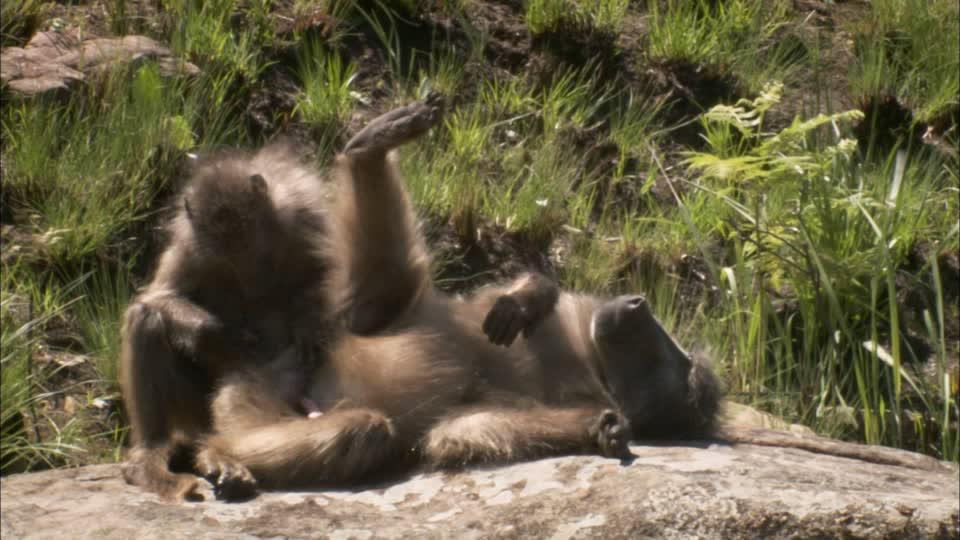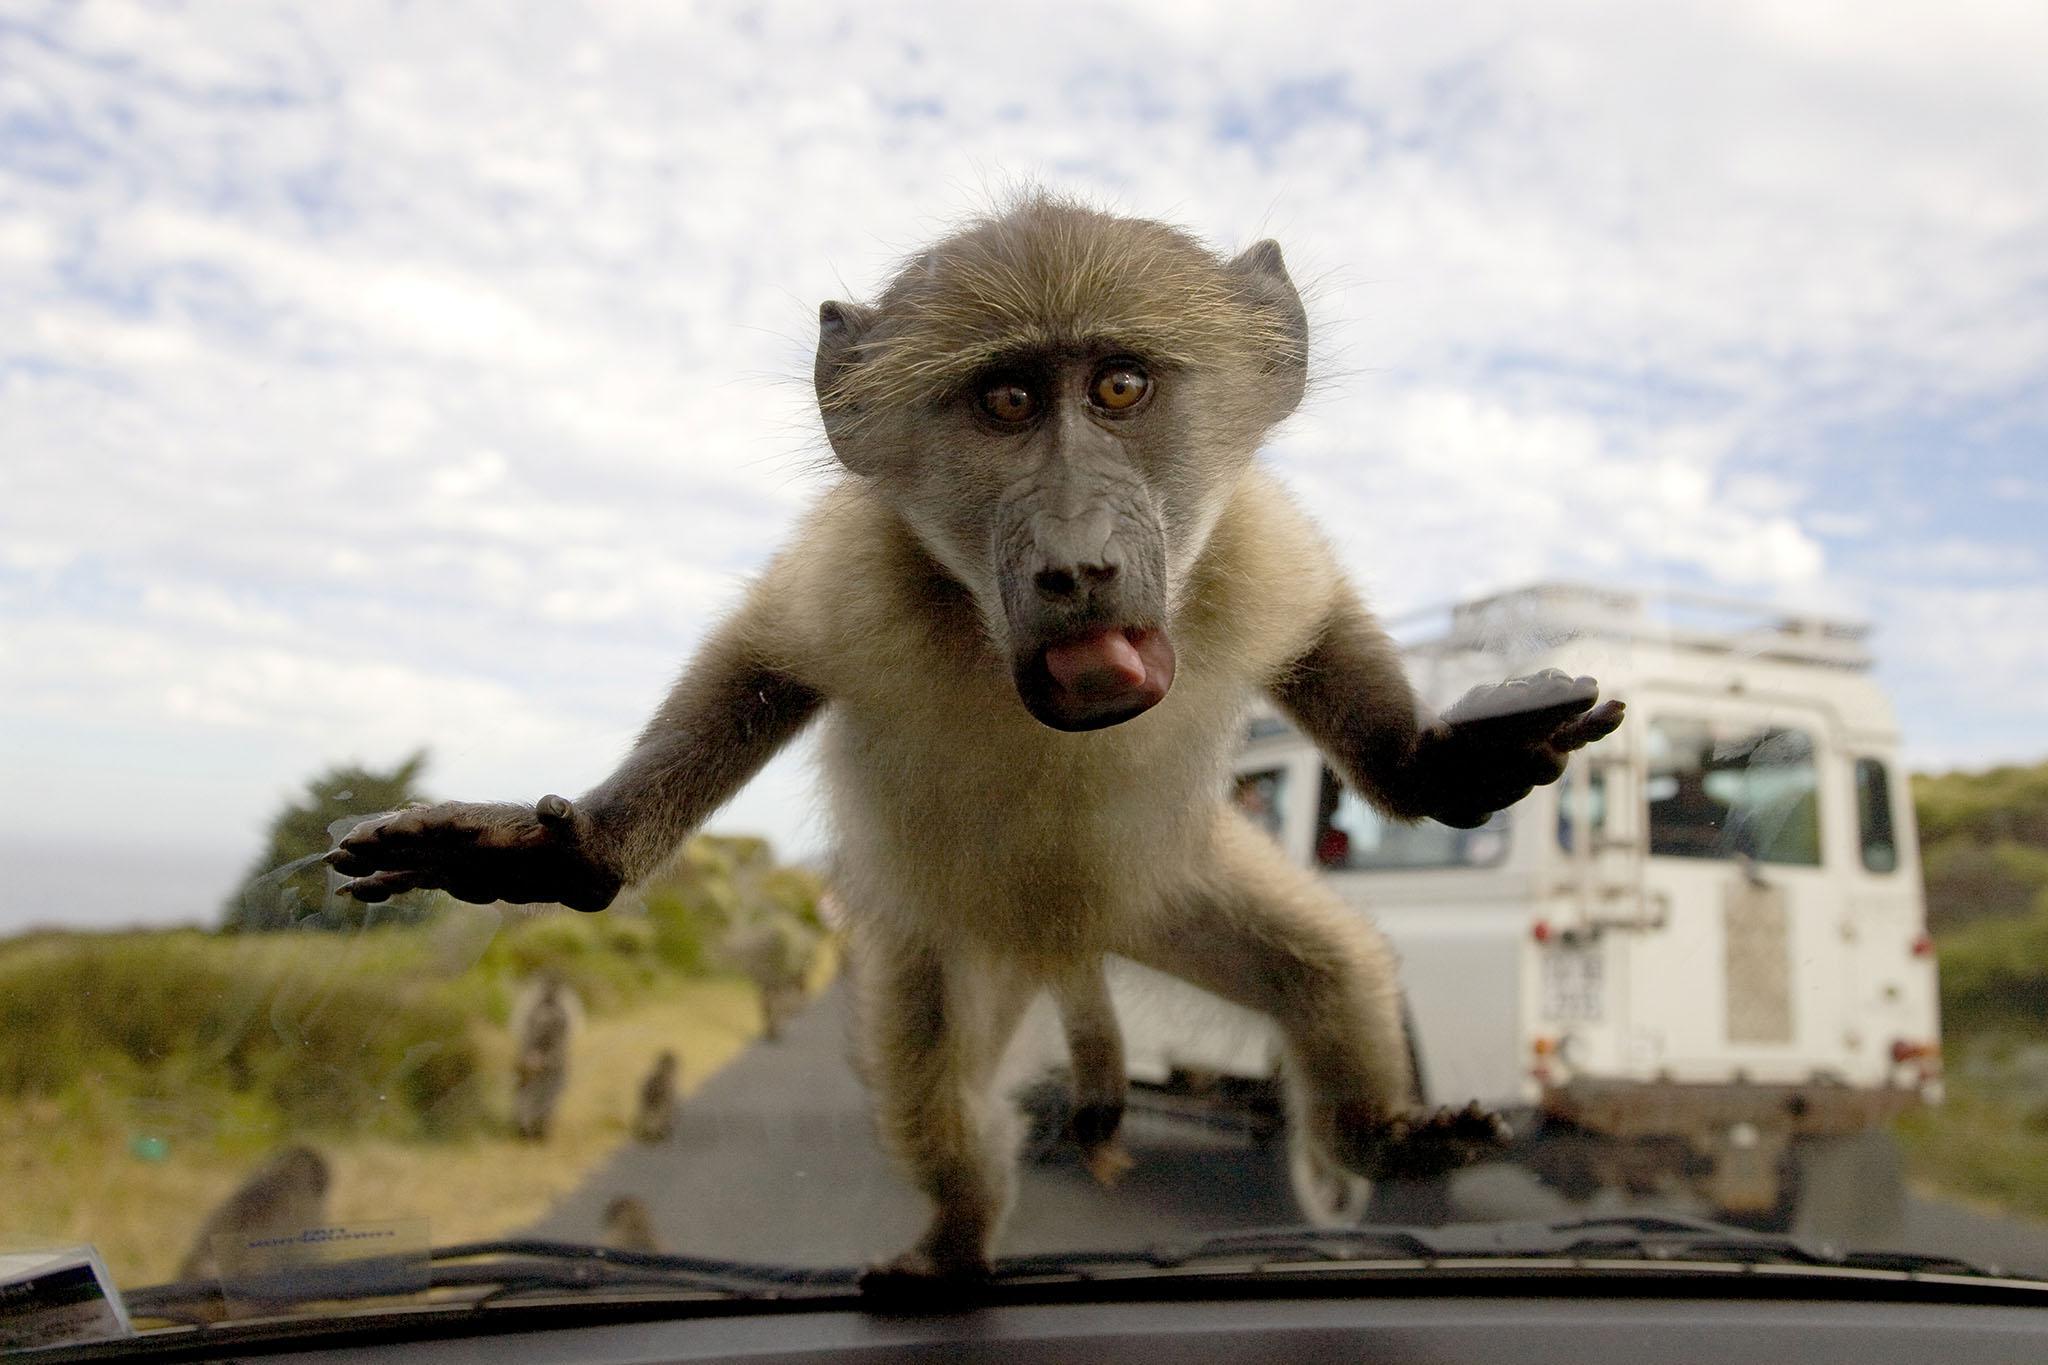The first image is the image on the left, the second image is the image on the right. For the images shown, is this caption "An older woman is showing some affection to a monkey." true? Answer yes or no. No. The first image is the image on the left, the second image is the image on the right. Analyze the images presented: Is the assertion "An elderly woman is touching the ape's face with her face." valid? Answer yes or no. No. 